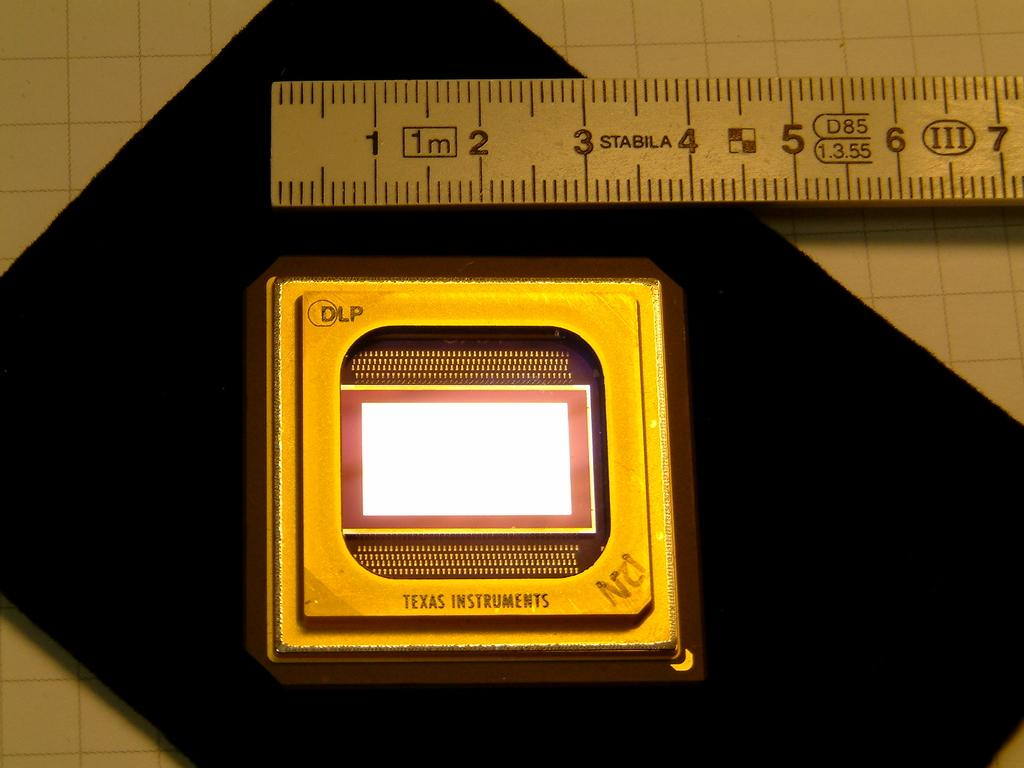<image>
Summarize the visual content of the image. A cpu processor by Texas Instrument sit on a black cloth near a ruller. 